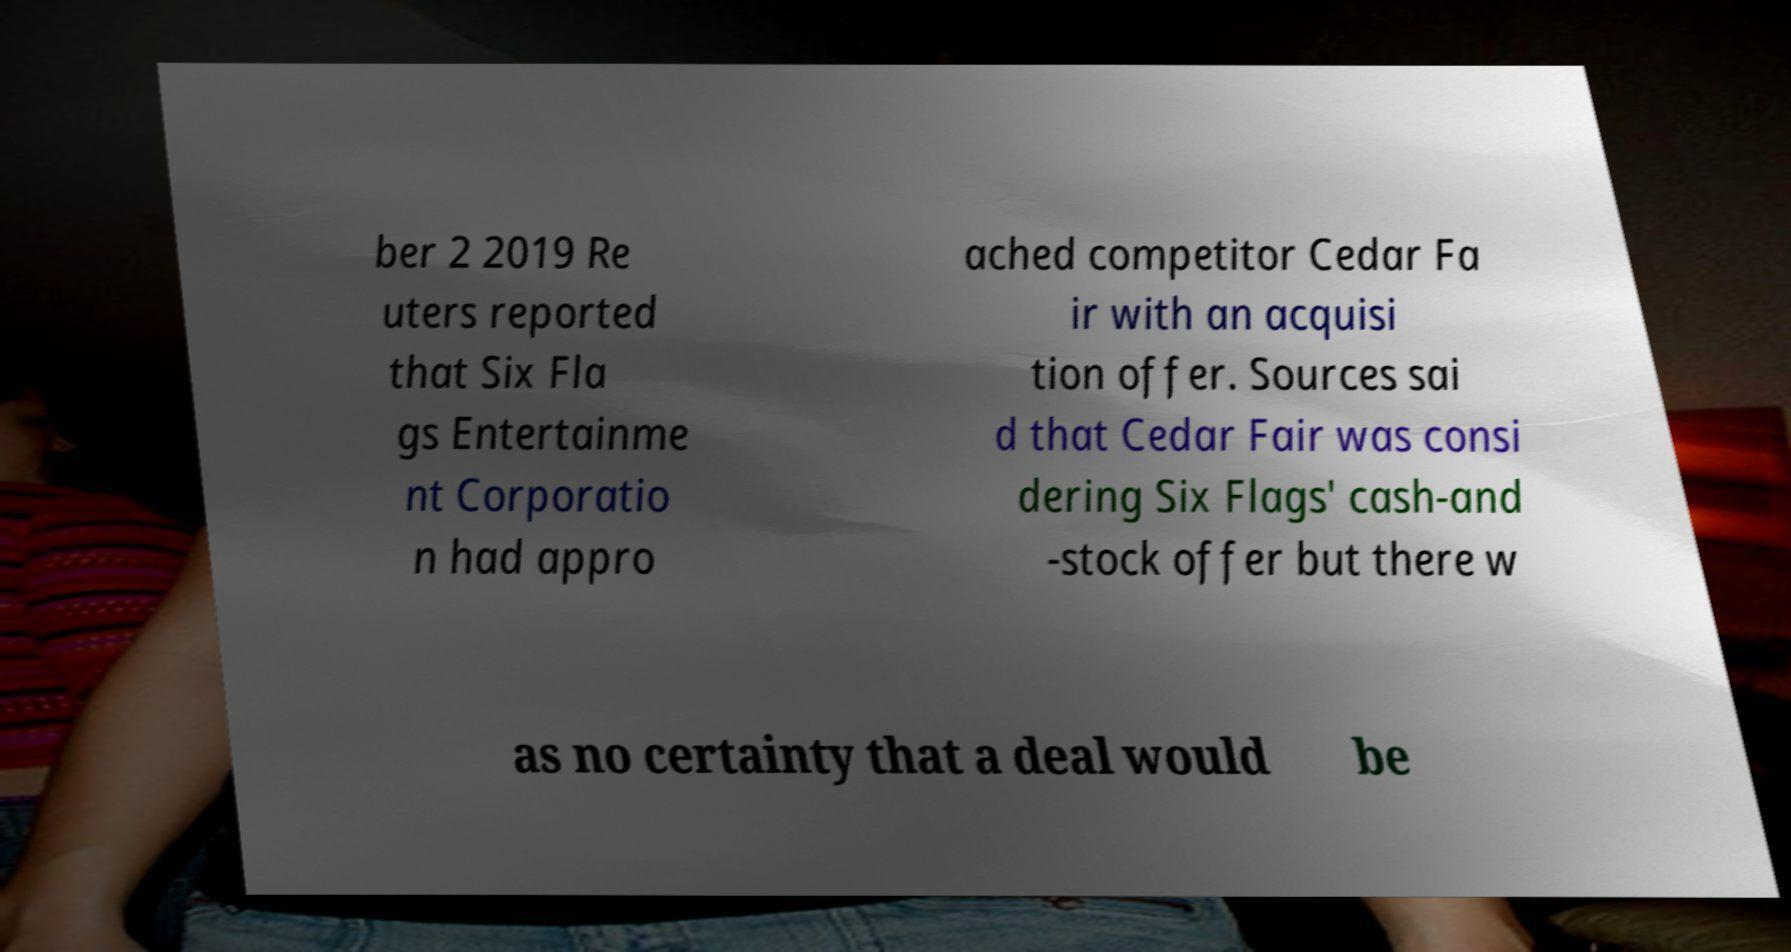Please read and relay the text visible in this image. What does it say? ber 2 2019 Re uters reported that Six Fla gs Entertainme nt Corporatio n had appro ached competitor Cedar Fa ir with an acquisi tion offer. Sources sai d that Cedar Fair was consi dering Six Flags' cash-and -stock offer but there w as no certainty that a deal would be 